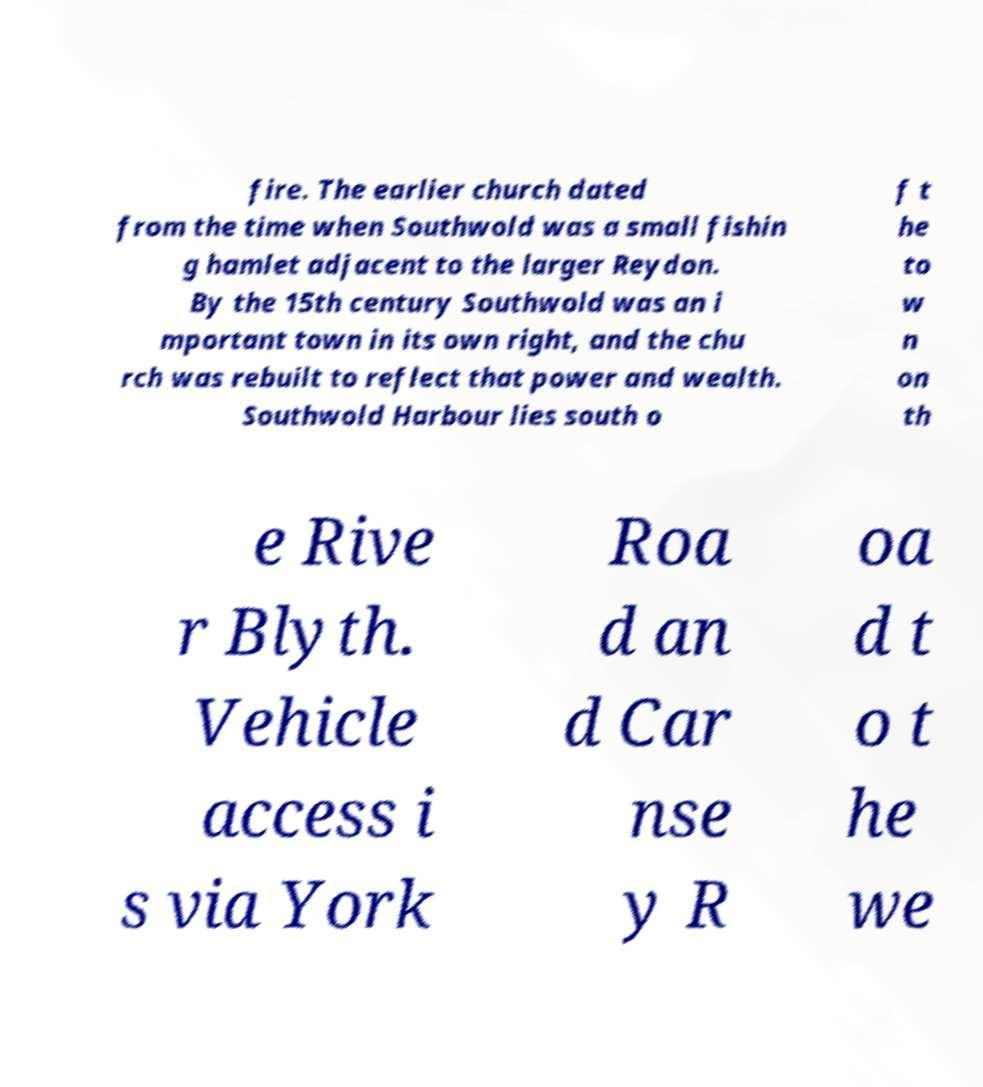Could you assist in decoding the text presented in this image and type it out clearly? fire. The earlier church dated from the time when Southwold was a small fishin g hamlet adjacent to the larger Reydon. By the 15th century Southwold was an i mportant town in its own right, and the chu rch was rebuilt to reflect that power and wealth. Southwold Harbour lies south o f t he to w n on th e Rive r Blyth. Vehicle access i s via York Roa d an d Car nse y R oa d t o t he we 